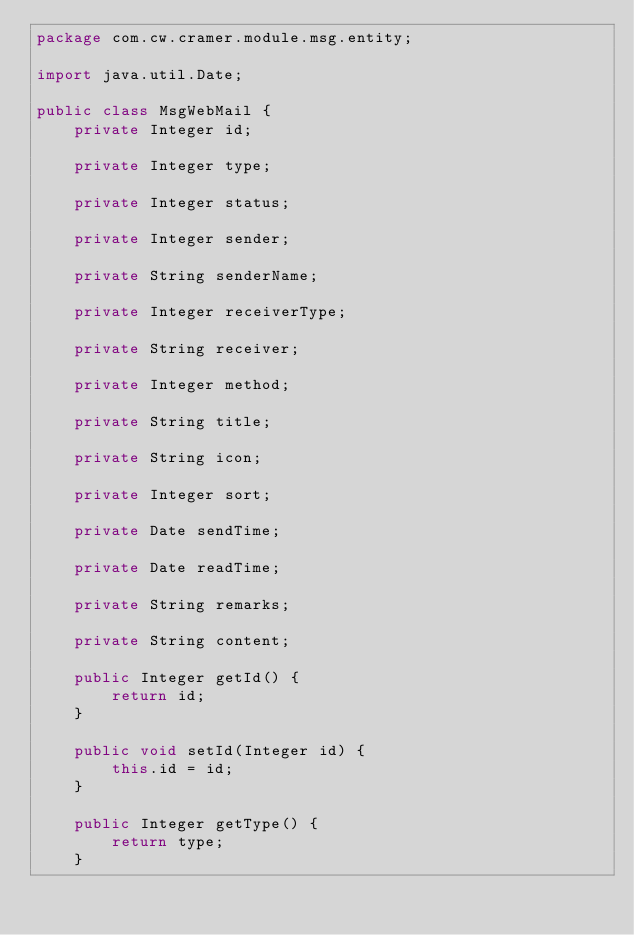Convert code to text. <code><loc_0><loc_0><loc_500><loc_500><_Java_>package com.cw.cramer.module.msg.entity;

import java.util.Date;

public class MsgWebMail {
    private Integer id;

    private Integer type;

    private Integer status;

    private Integer sender;
    
    private String senderName;

    private Integer receiverType;

    private String receiver;

    private Integer method;

    private String title;

    private String icon;

    private Integer sort;

    private Date sendTime;

    private Date readTime;

    private String remarks;

    private String content;

    public Integer getId() {
        return id;
    }

    public void setId(Integer id) {
        this.id = id;
    }

    public Integer getType() {
        return type;
    }
</code> 